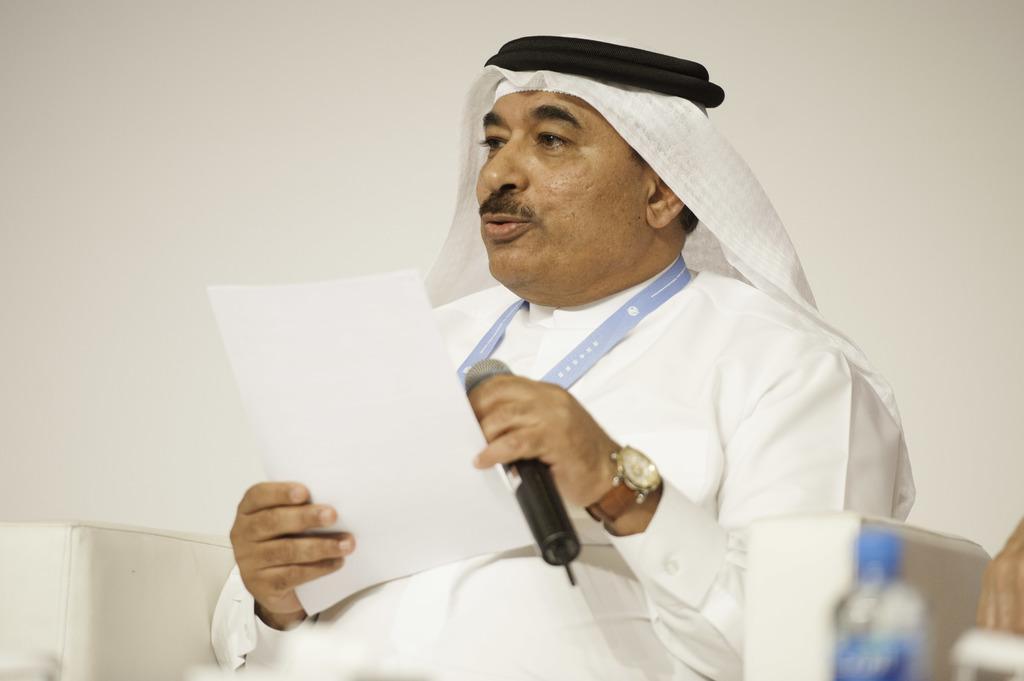Describe this image in one or two sentences. In the image I can see one person is sitting and holding the mike. On the left side of the image I can see the bottle. 